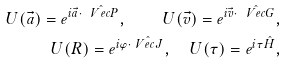<formula> <loc_0><loc_0><loc_500><loc_500>U ( \vec { a } ) = e ^ { i \vec { a } \cdot \hat { \ V e c { P } } } , \quad U ( \vec { v } ) = e ^ { i \vec { v } \cdot \hat { \ V e c { G } } } , \\ U ( R ) = e ^ { i \varphi \cdot \hat { \ V e c { J } } } , \quad U ( \tau ) = e ^ { i \tau \hat { H } } ,</formula> 